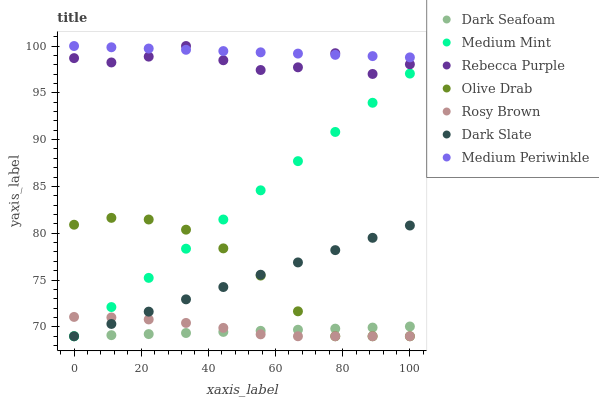Does Dark Seafoam have the minimum area under the curve?
Answer yes or no. Yes. Does Medium Periwinkle have the maximum area under the curve?
Answer yes or no. Yes. Does Rosy Brown have the minimum area under the curve?
Answer yes or no. No. Does Rosy Brown have the maximum area under the curve?
Answer yes or no. No. Is Medium Mint the smoothest?
Answer yes or no. Yes. Is Rebecca Purple the roughest?
Answer yes or no. Yes. Is Rosy Brown the smoothest?
Answer yes or no. No. Is Rosy Brown the roughest?
Answer yes or no. No. Does Medium Mint have the lowest value?
Answer yes or no. Yes. Does Medium Periwinkle have the lowest value?
Answer yes or no. No. Does Rebecca Purple have the highest value?
Answer yes or no. Yes. Does Rosy Brown have the highest value?
Answer yes or no. No. Is Dark Slate less than Medium Periwinkle?
Answer yes or no. Yes. Is Rebecca Purple greater than Medium Mint?
Answer yes or no. Yes. Does Dark Slate intersect Medium Mint?
Answer yes or no. Yes. Is Dark Slate less than Medium Mint?
Answer yes or no. No. Is Dark Slate greater than Medium Mint?
Answer yes or no. No. Does Dark Slate intersect Medium Periwinkle?
Answer yes or no. No. 